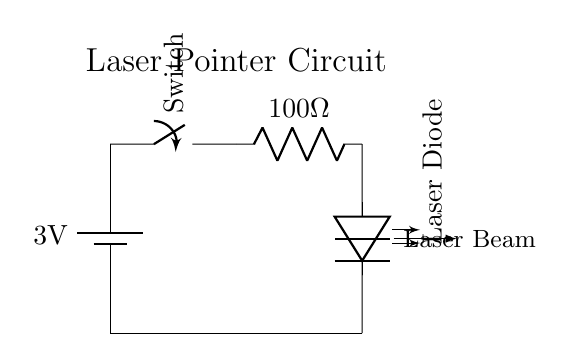What is the voltage of this circuit? The circuit shows a battery with a label indicating it provides a voltage of 3 volts. This is the potential difference available to the components in the circuit.
Answer: 3 volts What type of switch is used in this circuit? The circuit diagram features a switch labeled simply as "Switch." This indicates that it is a manual switch which can open or close the circuit.
Answer: Switch How many resistors are present in the circuit? A close examination of the diagram shows that there is one resistor labeled as 100 Ohms. This is the only resistor in the circuit.
Answer: 1 What component converts electrical energy into light? In the circuit, the component that performs this function is labeled as "Laser Diode." This indicates that it converts the electrical energy supplied by the circuit into a laser beam.
Answer: Laser Diode What is the resistance value in the circuit? The diagram specifies a resistor with a value of 100 Ohms. This is the resistance present in the circuit, influencing the current flow.
Answer: 100 Ohms What does the arrow indicate in the circuit near the laser diode? The arrow labeled "Laser Beam" indicates the output of the laser diode, showing the direction in which the laser is emitted when the circuit is complete.
Answer: Laser Beam How does closing the switch affect the circuit? Closing the switch completes the circuit, allowing current to flow from the battery through the resistor to the laser diode, enabling it to produce a laser output.
Answer: Completes the circuit 